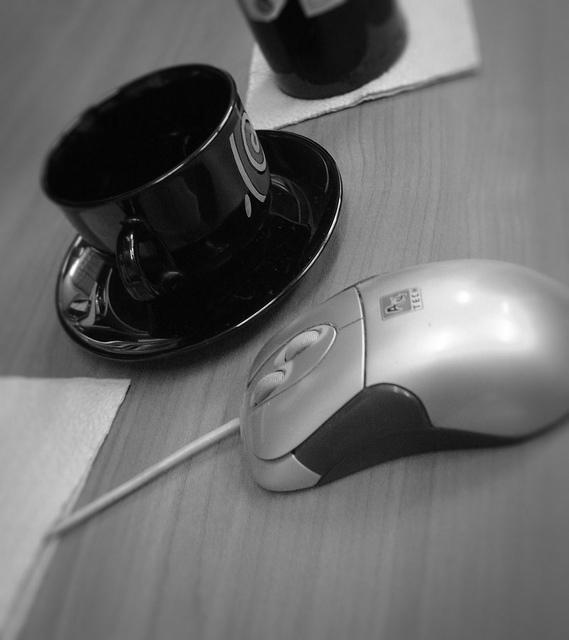How many cups are visible?
Give a very brief answer. 2. How many cows are standing?
Give a very brief answer. 0. 